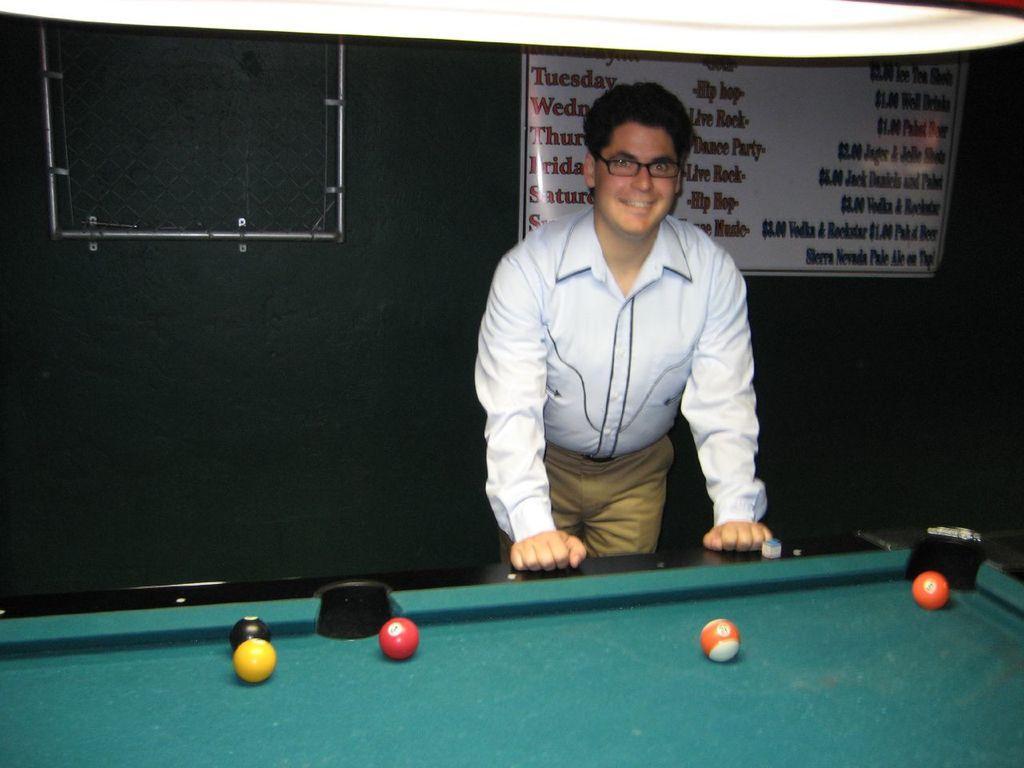In one or two sentences, can you explain what this image depicts? As we can see in the image there is a man standing over here, a banner and billiards board. 